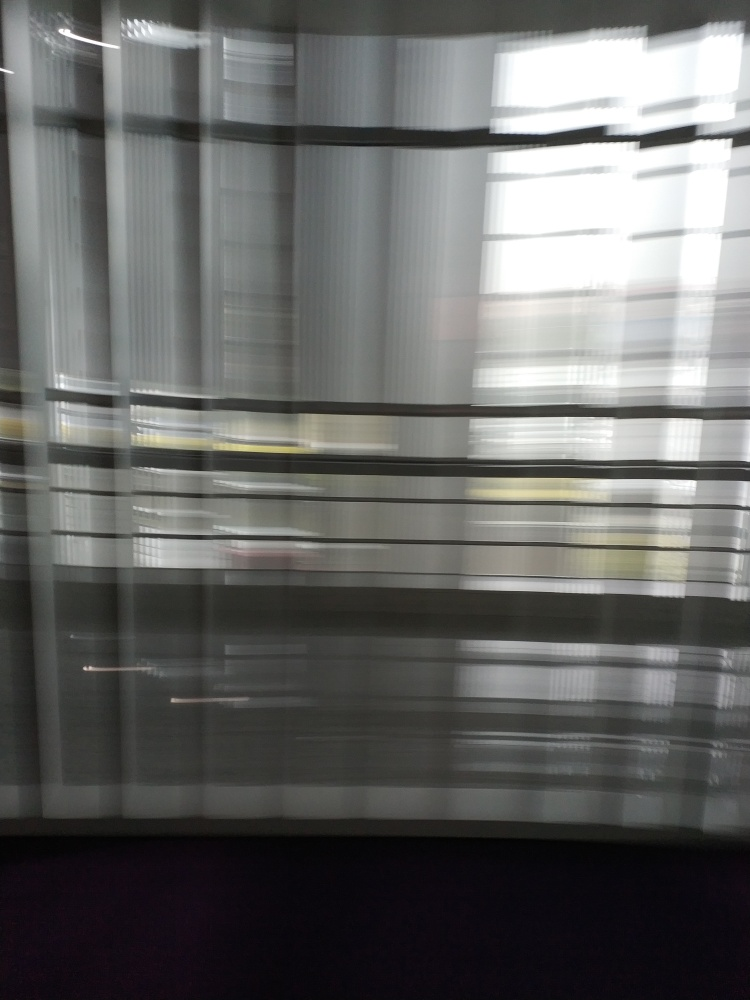What might be the reason behind taking a photo like this one? The photographer could have been trying to capture the essence of motion or creating an abstract image. Alternatively, it might have been an accidental shot taken while moving the camera. Could this technique be used purposefully for artistic expression? Absolutely, photographers often use intentional camera movement as a creative tool to produce images that focus more on form, color, and the flow of movement, rather than sharp detail. 